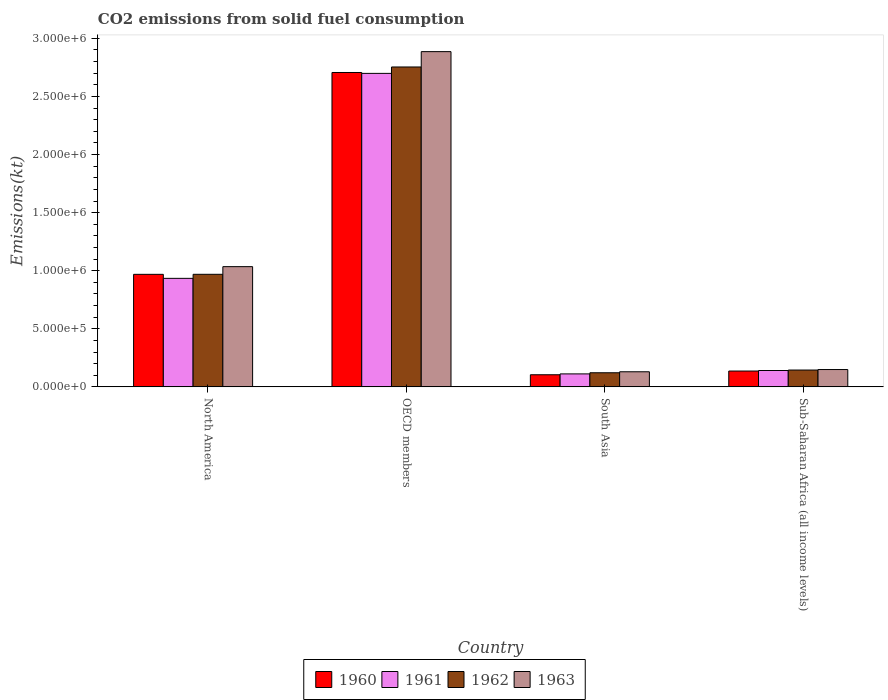How many different coloured bars are there?
Your response must be concise. 4. Are the number of bars per tick equal to the number of legend labels?
Your answer should be very brief. Yes. How many bars are there on the 1st tick from the left?
Keep it short and to the point. 4. What is the label of the 1st group of bars from the left?
Make the answer very short. North America. What is the amount of CO2 emitted in 1963 in North America?
Provide a short and direct response. 1.03e+06. Across all countries, what is the maximum amount of CO2 emitted in 1962?
Make the answer very short. 2.75e+06. Across all countries, what is the minimum amount of CO2 emitted in 1963?
Make the answer very short. 1.30e+05. In which country was the amount of CO2 emitted in 1960 maximum?
Make the answer very short. OECD members. In which country was the amount of CO2 emitted in 1962 minimum?
Provide a short and direct response. South Asia. What is the total amount of CO2 emitted in 1960 in the graph?
Give a very brief answer. 3.92e+06. What is the difference between the amount of CO2 emitted in 1962 in OECD members and that in Sub-Saharan Africa (all income levels)?
Provide a succinct answer. 2.61e+06. What is the difference between the amount of CO2 emitted in 1963 in Sub-Saharan Africa (all income levels) and the amount of CO2 emitted in 1962 in North America?
Provide a succinct answer. -8.20e+05. What is the average amount of CO2 emitted in 1963 per country?
Offer a terse response. 1.05e+06. What is the difference between the amount of CO2 emitted of/in 1960 and amount of CO2 emitted of/in 1962 in OECD members?
Offer a very short reply. -4.75e+04. In how many countries, is the amount of CO2 emitted in 1962 greater than 2100000 kt?
Your answer should be compact. 1. What is the ratio of the amount of CO2 emitted in 1960 in South Asia to that in Sub-Saharan Africa (all income levels)?
Give a very brief answer. 0.77. What is the difference between the highest and the second highest amount of CO2 emitted in 1962?
Your answer should be very brief. -2.61e+06. What is the difference between the highest and the lowest amount of CO2 emitted in 1963?
Provide a succinct answer. 2.76e+06. Is the sum of the amount of CO2 emitted in 1962 in North America and OECD members greater than the maximum amount of CO2 emitted in 1960 across all countries?
Your answer should be compact. Yes. What does the 2nd bar from the right in North America represents?
Give a very brief answer. 1962. How many bars are there?
Make the answer very short. 16. How many countries are there in the graph?
Your answer should be very brief. 4. Does the graph contain grids?
Offer a very short reply. No. Where does the legend appear in the graph?
Keep it short and to the point. Bottom center. How are the legend labels stacked?
Offer a terse response. Horizontal. What is the title of the graph?
Provide a short and direct response. CO2 emissions from solid fuel consumption. What is the label or title of the Y-axis?
Your answer should be very brief. Emissions(kt). What is the Emissions(kt) in 1960 in North America?
Keep it short and to the point. 9.69e+05. What is the Emissions(kt) in 1961 in North America?
Provide a short and direct response. 9.34e+05. What is the Emissions(kt) in 1962 in North America?
Your answer should be compact. 9.69e+05. What is the Emissions(kt) of 1963 in North America?
Offer a very short reply. 1.03e+06. What is the Emissions(kt) in 1960 in OECD members?
Give a very brief answer. 2.71e+06. What is the Emissions(kt) of 1961 in OECD members?
Ensure brevity in your answer.  2.70e+06. What is the Emissions(kt) of 1962 in OECD members?
Your response must be concise. 2.75e+06. What is the Emissions(kt) in 1963 in OECD members?
Your response must be concise. 2.89e+06. What is the Emissions(kt) in 1960 in South Asia?
Your response must be concise. 1.04e+05. What is the Emissions(kt) in 1961 in South Asia?
Provide a succinct answer. 1.12e+05. What is the Emissions(kt) in 1962 in South Asia?
Your response must be concise. 1.22e+05. What is the Emissions(kt) in 1963 in South Asia?
Your answer should be compact. 1.30e+05. What is the Emissions(kt) of 1960 in Sub-Saharan Africa (all income levels)?
Provide a succinct answer. 1.36e+05. What is the Emissions(kt) in 1961 in Sub-Saharan Africa (all income levels)?
Provide a succinct answer. 1.41e+05. What is the Emissions(kt) of 1962 in Sub-Saharan Africa (all income levels)?
Your response must be concise. 1.45e+05. What is the Emissions(kt) of 1963 in Sub-Saharan Africa (all income levels)?
Your answer should be very brief. 1.49e+05. Across all countries, what is the maximum Emissions(kt) in 1960?
Your response must be concise. 2.71e+06. Across all countries, what is the maximum Emissions(kt) in 1961?
Your answer should be very brief. 2.70e+06. Across all countries, what is the maximum Emissions(kt) in 1962?
Offer a very short reply. 2.75e+06. Across all countries, what is the maximum Emissions(kt) in 1963?
Provide a short and direct response. 2.89e+06. Across all countries, what is the minimum Emissions(kt) of 1960?
Offer a terse response. 1.04e+05. Across all countries, what is the minimum Emissions(kt) in 1961?
Make the answer very short. 1.12e+05. Across all countries, what is the minimum Emissions(kt) in 1962?
Provide a succinct answer. 1.22e+05. Across all countries, what is the minimum Emissions(kt) of 1963?
Offer a terse response. 1.30e+05. What is the total Emissions(kt) of 1960 in the graph?
Provide a short and direct response. 3.92e+06. What is the total Emissions(kt) of 1961 in the graph?
Your answer should be very brief. 3.89e+06. What is the total Emissions(kt) of 1962 in the graph?
Offer a very short reply. 3.99e+06. What is the total Emissions(kt) of 1963 in the graph?
Your answer should be compact. 4.20e+06. What is the difference between the Emissions(kt) in 1960 in North America and that in OECD members?
Provide a short and direct response. -1.74e+06. What is the difference between the Emissions(kt) in 1961 in North America and that in OECD members?
Provide a succinct answer. -1.76e+06. What is the difference between the Emissions(kt) of 1962 in North America and that in OECD members?
Your answer should be very brief. -1.78e+06. What is the difference between the Emissions(kt) in 1963 in North America and that in OECD members?
Provide a succinct answer. -1.85e+06. What is the difference between the Emissions(kt) of 1960 in North America and that in South Asia?
Your response must be concise. 8.65e+05. What is the difference between the Emissions(kt) of 1961 in North America and that in South Asia?
Make the answer very short. 8.22e+05. What is the difference between the Emissions(kt) of 1962 in North America and that in South Asia?
Keep it short and to the point. 8.48e+05. What is the difference between the Emissions(kt) of 1963 in North America and that in South Asia?
Give a very brief answer. 9.05e+05. What is the difference between the Emissions(kt) of 1960 in North America and that in Sub-Saharan Africa (all income levels)?
Provide a short and direct response. 8.33e+05. What is the difference between the Emissions(kt) in 1961 in North America and that in Sub-Saharan Africa (all income levels)?
Offer a very short reply. 7.93e+05. What is the difference between the Emissions(kt) of 1962 in North America and that in Sub-Saharan Africa (all income levels)?
Your answer should be very brief. 8.24e+05. What is the difference between the Emissions(kt) in 1963 in North America and that in Sub-Saharan Africa (all income levels)?
Your response must be concise. 8.86e+05. What is the difference between the Emissions(kt) in 1960 in OECD members and that in South Asia?
Provide a succinct answer. 2.60e+06. What is the difference between the Emissions(kt) of 1961 in OECD members and that in South Asia?
Offer a terse response. 2.59e+06. What is the difference between the Emissions(kt) in 1962 in OECD members and that in South Asia?
Give a very brief answer. 2.63e+06. What is the difference between the Emissions(kt) of 1963 in OECD members and that in South Asia?
Your response must be concise. 2.76e+06. What is the difference between the Emissions(kt) of 1960 in OECD members and that in Sub-Saharan Africa (all income levels)?
Make the answer very short. 2.57e+06. What is the difference between the Emissions(kt) in 1961 in OECD members and that in Sub-Saharan Africa (all income levels)?
Keep it short and to the point. 2.56e+06. What is the difference between the Emissions(kt) of 1962 in OECD members and that in Sub-Saharan Africa (all income levels)?
Offer a terse response. 2.61e+06. What is the difference between the Emissions(kt) of 1963 in OECD members and that in Sub-Saharan Africa (all income levels)?
Offer a terse response. 2.74e+06. What is the difference between the Emissions(kt) of 1960 in South Asia and that in Sub-Saharan Africa (all income levels)?
Your answer should be compact. -3.20e+04. What is the difference between the Emissions(kt) in 1961 in South Asia and that in Sub-Saharan Africa (all income levels)?
Make the answer very short. -2.92e+04. What is the difference between the Emissions(kt) of 1962 in South Asia and that in Sub-Saharan Africa (all income levels)?
Offer a very short reply. -2.33e+04. What is the difference between the Emissions(kt) of 1963 in South Asia and that in Sub-Saharan Africa (all income levels)?
Offer a very short reply. -1.93e+04. What is the difference between the Emissions(kt) of 1960 in North America and the Emissions(kt) of 1961 in OECD members?
Your answer should be compact. -1.73e+06. What is the difference between the Emissions(kt) of 1960 in North America and the Emissions(kt) of 1962 in OECD members?
Make the answer very short. -1.79e+06. What is the difference between the Emissions(kt) of 1960 in North America and the Emissions(kt) of 1963 in OECD members?
Provide a succinct answer. -1.92e+06. What is the difference between the Emissions(kt) of 1961 in North America and the Emissions(kt) of 1962 in OECD members?
Provide a short and direct response. -1.82e+06. What is the difference between the Emissions(kt) in 1961 in North America and the Emissions(kt) in 1963 in OECD members?
Offer a very short reply. -1.95e+06. What is the difference between the Emissions(kt) in 1962 in North America and the Emissions(kt) in 1963 in OECD members?
Keep it short and to the point. -1.92e+06. What is the difference between the Emissions(kt) in 1960 in North America and the Emissions(kt) in 1961 in South Asia?
Your answer should be compact. 8.57e+05. What is the difference between the Emissions(kt) of 1960 in North America and the Emissions(kt) of 1962 in South Asia?
Provide a succinct answer. 8.47e+05. What is the difference between the Emissions(kt) of 1960 in North America and the Emissions(kt) of 1963 in South Asia?
Keep it short and to the point. 8.39e+05. What is the difference between the Emissions(kt) of 1961 in North America and the Emissions(kt) of 1962 in South Asia?
Ensure brevity in your answer.  8.13e+05. What is the difference between the Emissions(kt) of 1961 in North America and the Emissions(kt) of 1963 in South Asia?
Offer a very short reply. 8.04e+05. What is the difference between the Emissions(kt) in 1962 in North America and the Emissions(kt) in 1963 in South Asia?
Ensure brevity in your answer.  8.39e+05. What is the difference between the Emissions(kt) of 1960 in North America and the Emissions(kt) of 1961 in Sub-Saharan Africa (all income levels)?
Ensure brevity in your answer.  8.28e+05. What is the difference between the Emissions(kt) in 1960 in North America and the Emissions(kt) in 1962 in Sub-Saharan Africa (all income levels)?
Make the answer very short. 8.24e+05. What is the difference between the Emissions(kt) in 1960 in North America and the Emissions(kt) in 1963 in Sub-Saharan Africa (all income levels)?
Keep it short and to the point. 8.20e+05. What is the difference between the Emissions(kt) of 1961 in North America and the Emissions(kt) of 1962 in Sub-Saharan Africa (all income levels)?
Your answer should be compact. 7.89e+05. What is the difference between the Emissions(kt) in 1961 in North America and the Emissions(kt) in 1963 in Sub-Saharan Africa (all income levels)?
Your response must be concise. 7.85e+05. What is the difference between the Emissions(kt) in 1962 in North America and the Emissions(kt) in 1963 in Sub-Saharan Africa (all income levels)?
Offer a terse response. 8.20e+05. What is the difference between the Emissions(kt) of 1960 in OECD members and the Emissions(kt) of 1961 in South Asia?
Your answer should be compact. 2.59e+06. What is the difference between the Emissions(kt) of 1960 in OECD members and the Emissions(kt) of 1962 in South Asia?
Make the answer very short. 2.58e+06. What is the difference between the Emissions(kt) of 1960 in OECD members and the Emissions(kt) of 1963 in South Asia?
Give a very brief answer. 2.58e+06. What is the difference between the Emissions(kt) in 1961 in OECD members and the Emissions(kt) in 1962 in South Asia?
Ensure brevity in your answer.  2.58e+06. What is the difference between the Emissions(kt) in 1961 in OECD members and the Emissions(kt) in 1963 in South Asia?
Provide a succinct answer. 2.57e+06. What is the difference between the Emissions(kt) in 1962 in OECD members and the Emissions(kt) in 1963 in South Asia?
Keep it short and to the point. 2.62e+06. What is the difference between the Emissions(kt) of 1960 in OECD members and the Emissions(kt) of 1961 in Sub-Saharan Africa (all income levels)?
Your response must be concise. 2.57e+06. What is the difference between the Emissions(kt) of 1960 in OECD members and the Emissions(kt) of 1962 in Sub-Saharan Africa (all income levels)?
Your answer should be very brief. 2.56e+06. What is the difference between the Emissions(kt) of 1960 in OECD members and the Emissions(kt) of 1963 in Sub-Saharan Africa (all income levels)?
Your answer should be very brief. 2.56e+06. What is the difference between the Emissions(kt) of 1961 in OECD members and the Emissions(kt) of 1962 in Sub-Saharan Africa (all income levels)?
Keep it short and to the point. 2.55e+06. What is the difference between the Emissions(kt) in 1961 in OECD members and the Emissions(kt) in 1963 in Sub-Saharan Africa (all income levels)?
Provide a succinct answer. 2.55e+06. What is the difference between the Emissions(kt) of 1962 in OECD members and the Emissions(kt) of 1963 in Sub-Saharan Africa (all income levels)?
Keep it short and to the point. 2.60e+06. What is the difference between the Emissions(kt) of 1960 in South Asia and the Emissions(kt) of 1961 in Sub-Saharan Africa (all income levels)?
Your answer should be compact. -3.66e+04. What is the difference between the Emissions(kt) of 1960 in South Asia and the Emissions(kt) of 1962 in Sub-Saharan Africa (all income levels)?
Provide a succinct answer. -4.06e+04. What is the difference between the Emissions(kt) in 1960 in South Asia and the Emissions(kt) in 1963 in Sub-Saharan Africa (all income levels)?
Provide a short and direct response. -4.49e+04. What is the difference between the Emissions(kt) of 1961 in South Asia and the Emissions(kt) of 1962 in Sub-Saharan Africa (all income levels)?
Ensure brevity in your answer.  -3.31e+04. What is the difference between the Emissions(kt) of 1961 in South Asia and the Emissions(kt) of 1963 in Sub-Saharan Africa (all income levels)?
Provide a short and direct response. -3.75e+04. What is the difference between the Emissions(kt) in 1962 in South Asia and the Emissions(kt) in 1963 in Sub-Saharan Africa (all income levels)?
Your answer should be very brief. -2.77e+04. What is the average Emissions(kt) in 1960 per country?
Your response must be concise. 9.79e+05. What is the average Emissions(kt) in 1961 per country?
Keep it short and to the point. 9.71e+05. What is the average Emissions(kt) in 1962 per country?
Keep it short and to the point. 9.97e+05. What is the average Emissions(kt) of 1963 per country?
Make the answer very short. 1.05e+06. What is the difference between the Emissions(kt) in 1960 and Emissions(kt) in 1961 in North America?
Make the answer very short. 3.46e+04. What is the difference between the Emissions(kt) of 1960 and Emissions(kt) of 1962 in North America?
Give a very brief answer. -249.46. What is the difference between the Emissions(kt) in 1960 and Emissions(kt) in 1963 in North America?
Make the answer very short. -6.61e+04. What is the difference between the Emissions(kt) in 1961 and Emissions(kt) in 1962 in North America?
Give a very brief answer. -3.49e+04. What is the difference between the Emissions(kt) of 1961 and Emissions(kt) of 1963 in North America?
Keep it short and to the point. -1.01e+05. What is the difference between the Emissions(kt) of 1962 and Emissions(kt) of 1963 in North America?
Provide a succinct answer. -6.58e+04. What is the difference between the Emissions(kt) of 1960 and Emissions(kt) of 1961 in OECD members?
Your response must be concise. 7787.15. What is the difference between the Emissions(kt) of 1960 and Emissions(kt) of 1962 in OECD members?
Provide a succinct answer. -4.75e+04. What is the difference between the Emissions(kt) of 1960 and Emissions(kt) of 1963 in OECD members?
Provide a short and direct response. -1.79e+05. What is the difference between the Emissions(kt) in 1961 and Emissions(kt) in 1962 in OECD members?
Your answer should be compact. -5.52e+04. What is the difference between the Emissions(kt) of 1961 and Emissions(kt) of 1963 in OECD members?
Your answer should be very brief. -1.87e+05. What is the difference between the Emissions(kt) of 1962 and Emissions(kt) of 1963 in OECD members?
Offer a very short reply. -1.32e+05. What is the difference between the Emissions(kt) in 1960 and Emissions(kt) in 1961 in South Asia?
Make the answer very short. -7419.38. What is the difference between the Emissions(kt) in 1960 and Emissions(kt) in 1962 in South Asia?
Give a very brief answer. -1.72e+04. What is the difference between the Emissions(kt) in 1960 and Emissions(kt) in 1963 in South Asia?
Give a very brief answer. -2.57e+04. What is the difference between the Emissions(kt) in 1961 and Emissions(kt) in 1962 in South Asia?
Your answer should be very brief. -9815.22. What is the difference between the Emissions(kt) in 1961 and Emissions(kt) in 1963 in South Asia?
Provide a short and direct response. -1.82e+04. What is the difference between the Emissions(kt) in 1962 and Emissions(kt) in 1963 in South Asia?
Offer a very short reply. -8416.72. What is the difference between the Emissions(kt) of 1960 and Emissions(kt) of 1961 in Sub-Saharan Africa (all income levels)?
Your response must be concise. -4614.59. What is the difference between the Emissions(kt) of 1960 and Emissions(kt) of 1962 in Sub-Saharan Africa (all income levels)?
Provide a succinct answer. -8598.99. What is the difference between the Emissions(kt) in 1960 and Emissions(kt) in 1963 in Sub-Saharan Africa (all income levels)?
Offer a very short reply. -1.30e+04. What is the difference between the Emissions(kt) of 1961 and Emissions(kt) of 1962 in Sub-Saharan Africa (all income levels)?
Offer a terse response. -3984.4. What is the difference between the Emissions(kt) of 1961 and Emissions(kt) of 1963 in Sub-Saharan Africa (all income levels)?
Offer a very short reply. -8360.18. What is the difference between the Emissions(kt) in 1962 and Emissions(kt) in 1963 in Sub-Saharan Africa (all income levels)?
Your answer should be compact. -4375.77. What is the ratio of the Emissions(kt) of 1960 in North America to that in OECD members?
Provide a short and direct response. 0.36. What is the ratio of the Emissions(kt) in 1961 in North America to that in OECD members?
Provide a short and direct response. 0.35. What is the ratio of the Emissions(kt) in 1962 in North America to that in OECD members?
Ensure brevity in your answer.  0.35. What is the ratio of the Emissions(kt) in 1963 in North America to that in OECD members?
Give a very brief answer. 0.36. What is the ratio of the Emissions(kt) in 1960 in North America to that in South Asia?
Make the answer very short. 9.29. What is the ratio of the Emissions(kt) of 1961 in North America to that in South Asia?
Provide a succinct answer. 8.36. What is the ratio of the Emissions(kt) of 1962 in North America to that in South Asia?
Give a very brief answer. 7.97. What is the ratio of the Emissions(kt) of 1963 in North America to that in South Asia?
Your answer should be very brief. 7.96. What is the ratio of the Emissions(kt) in 1960 in North America to that in Sub-Saharan Africa (all income levels)?
Offer a terse response. 7.11. What is the ratio of the Emissions(kt) in 1961 in North America to that in Sub-Saharan Africa (all income levels)?
Offer a terse response. 6.63. What is the ratio of the Emissions(kt) in 1962 in North America to that in Sub-Saharan Africa (all income levels)?
Provide a short and direct response. 6.69. What is the ratio of the Emissions(kt) in 1963 in North America to that in Sub-Saharan Africa (all income levels)?
Provide a short and direct response. 6.93. What is the ratio of the Emissions(kt) in 1960 in OECD members to that in South Asia?
Offer a very short reply. 25.95. What is the ratio of the Emissions(kt) of 1961 in OECD members to that in South Asia?
Offer a very short reply. 24.16. What is the ratio of the Emissions(kt) of 1962 in OECD members to that in South Asia?
Keep it short and to the point. 22.66. What is the ratio of the Emissions(kt) in 1963 in OECD members to that in South Asia?
Make the answer very short. 22.21. What is the ratio of the Emissions(kt) in 1960 in OECD members to that in Sub-Saharan Africa (all income levels)?
Offer a very short reply. 19.86. What is the ratio of the Emissions(kt) of 1961 in OECD members to that in Sub-Saharan Africa (all income levels)?
Ensure brevity in your answer.  19.16. What is the ratio of the Emissions(kt) in 1962 in OECD members to that in Sub-Saharan Africa (all income levels)?
Offer a terse response. 19.01. What is the ratio of the Emissions(kt) in 1963 in OECD members to that in Sub-Saharan Africa (all income levels)?
Offer a very short reply. 19.34. What is the ratio of the Emissions(kt) of 1960 in South Asia to that in Sub-Saharan Africa (all income levels)?
Ensure brevity in your answer.  0.77. What is the ratio of the Emissions(kt) in 1961 in South Asia to that in Sub-Saharan Africa (all income levels)?
Offer a very short reply. 0.79. What is the ratio of the Emissions(kt) of 1962 in South Asia to that in Sub-Saharan Africa (all income levels)?
Keep it short and to the point. 0.84. What is the ratio of the Emissions(kt) of 1963 in South Asia to that in Sub-Saharan Africa (all income levels)?
Offer a terse response. 0.87. What is the difference between the highest and the second highest Emissions(kt) in 1960?
Offer a terse response. 1.74e+06. What is the difference between the highest and the second highest Emissions(kt) of 1961?
Ensure brevity in your answer.  1.76e+06. What is the difference between the highest and the second highest Emissions(kt) of 1962?
Offer a terse response. 1.78e+06. What is the difference between the highest and the second highest Emissions(kt) in 1963?
Give a very brief answer. 1.85e+06. What is the difference between the highest and the lowest Emissions(kt) in 1960?
Provide a succinct answer. 2.60e+06. What is the difference between the highest and the lowest Emissions(kt) of 1961?
Offer a very short reply. 2.59e+06. What is the difference between the highest and the lowest Emissions(kt) of 1962?
Offer a very short reply. 2.63e+06. What is the difference between the highest and the lowest Emissions(kt) in 1963?
Your answer should be compact. 2.76e+06. 